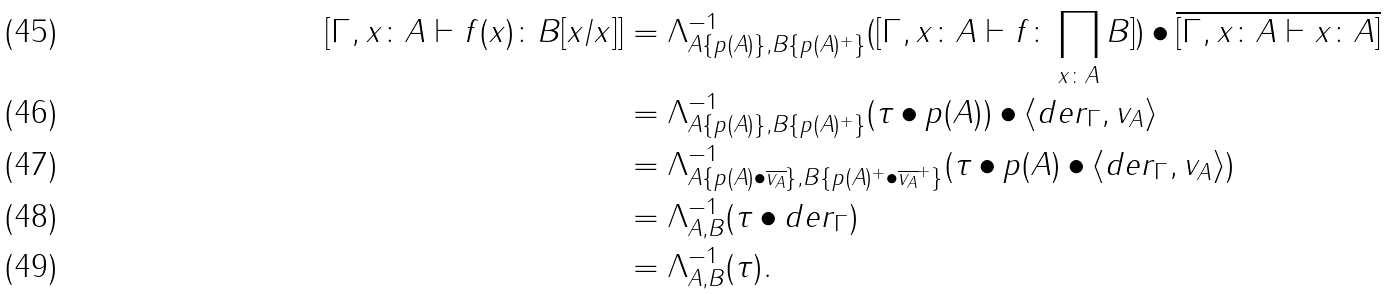Convert formula to latex. <formula><loc_0><loc_0><loc_500><loc_500>[ \Gamma , x \colon A \vdash f ( x ) \colon B [ x / x ] ] & = \Lambda _ { A \{ p ( A ) \} , B \{ p ( A ) ^ { + } \} } ^ { - 1 } ( [ \Gamma , x \colon A \vdash f \colon \prod _ { x \colon A } B ] ) \bullet \overline { [ \Gamma , x \colon A \vdash x \colon A ] } \\ & = \Lambda _ { A \{ p ( A ) \} , B \{ p ( A ) ^ { + } \} } ^ { - 1 } ( \tau \bullet p ( A ) ) \bullet \langle d e r _ { \Gamma } , v _ { A } \rangle \\ & = \Lambda _ { A \{ p ( A ) \bullet \overline { v _ { A } } \} , B \{ p ( A ) ^ { + } \bullet \overline { v _ { A } } ^ { + } \} } ^ { - 1 } ( \tau \bullet p ( A ) \bullet \langle d e r _ { \Gamma } , v _ { A } \rangle ) \\ & = \Lambda _ { A , B } ^ { - 1 } ( \tau \bullet d e r _ { \Gamma } ) \\ & = \Lambda _ { A , B } ^ { - 1 } ( \tau ) .</formula> 